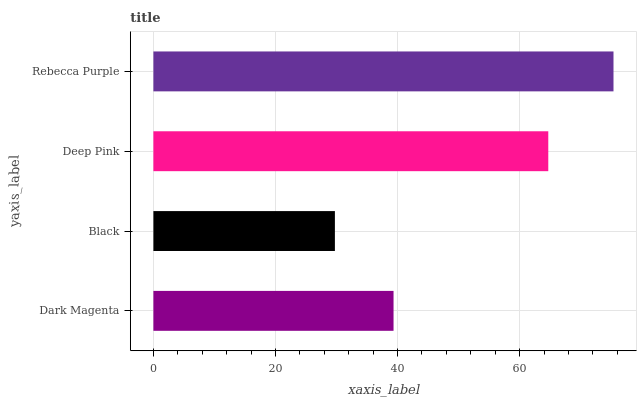Is Black the minimum?
Answer yes or no. Yes. Is Rebecca Purple the maximum?
Answer yes or no. Yes. Is Deep Pink the minimum?
Answer yes or no. No. Is Deep Pink the maximum?
Answer yes or no. No. Is Deep Pink greater than Black?
Answer yes or no. Yes. Is Black less than Deep Pink?
Answer yes or no. Yes. Is Black greater than Deep Pink?
Answer yes or no. No. Is Deep Pink less than Black?
Answer yes or no. No. Is Deep Pink the high median?
Answer yes or no. Yes. Is Dark Magenta the low median?
Answer yes or no. Yes. Is Dark Magenta the high median?
Answer yes or no. No. Is Black the low median?
Answer yes or no. No. 